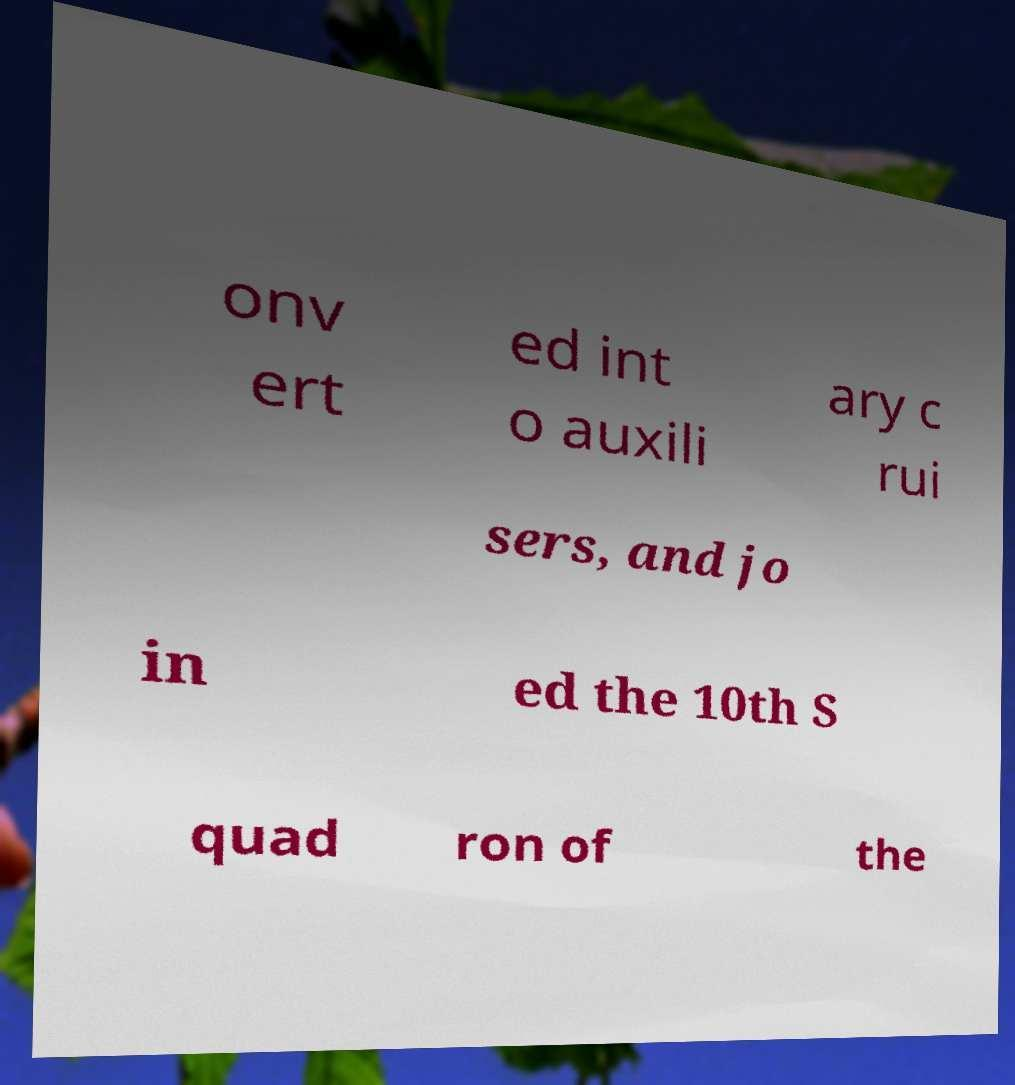Could you assist in decoding the text presented in this image and type it out clearly? onv ert ed int o auxili ary c rui sers, and jo in ed the 10th S quad ron of the 